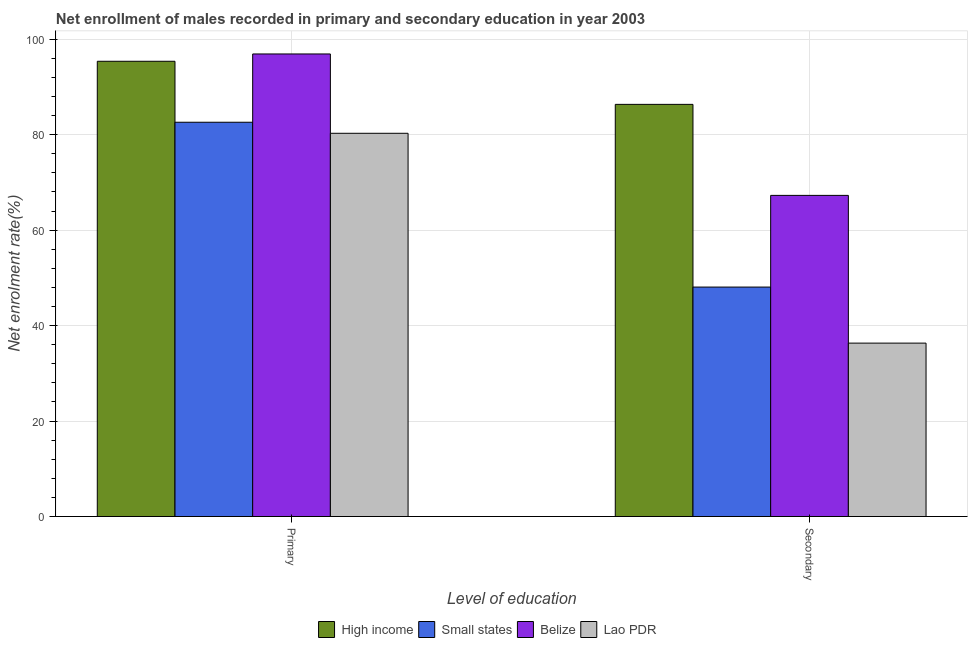How many different coloured bars are there?
Offer a very short reply. 4. How many groups of bars are there?
Provide a short and direct response. 2. Are the number of bars per tick equal to the number of legend labels?
Make the answer very short. Yes. Are the number of bars on each tick of the X-axis equal?
Keep it short and to the point. Yes. How many bars are there on the 1st tick from the left?
Offer a very short reply. 4. How many bars are there on the 1st tick from the right?
Your response must be concise. 4. What is the label of the 2nd group of bars from the left?
Offer a very short reply. Secondary. What is the enrollment rate in primary education in Lao PDR?
Keep it short and to the point. 80.28. Across all countries, what is the maximum enrollment rate in secondary education?
Give a very brief answer. 86.34. Across all countries, what is the minimum enrollment rate in primary education?
Give a very brief answer. 80.28. In which country was the enrollment rate in secondary education maximum?
Give a very brief answer. High income. In which country was the enrollment rate in primary education minimum?
Ensure brevity in your answer.  Lao PDR. What is the total enrollment rate in primary education in the graph?
Provide a succinct answer. 355.14. What is the difference between the enrollment rate in secondary education in Small states and that in Belize?
Offer a very short reply. -19.21. What is the difference between the enrollment rate in primary education in Belize and the enrollment rate in secondary education in High income?
Give a very brief answer. 10.56. What is the average enrollment rate in secondary education per country?
Offer a terse response. 59.5. What is the difference between the enrollment rate in secondary education and enrollment rate in primary education in High income?
Provide a short and direct response. -9.03. What is the ratio of the enrollment rate in primary education in Small states to that in Belize?
Your response must be concise. 0.85. Is the enrollment rate in primary education in Lao PDR less than that in Belize?
Keep it short and to the point. Yes. In how many countries, is the enrollment rate in primary education greater than the average enrollment rate in primary education taken over all countries?
Give a very brief answer. 2. What does the 1st bar from the left in Primary represents?
Your answer should be compact. High income. What does the 2nd bar from the right in Secondary represents?
Make the answer very short. Belize. How many countries are there in the graph?
Offer a very short reply. 4. Are the values on the major ticks of Y-axis written in scientific E-notation?
Keep it short and to the point. No. Does the graph contain grids?
Offer a very short reply. Yes. How many legend labels are there?
Keep it short and to the point. 4. What is the title of the graph?
Offer a terse response. Net enrollment of males recorded in primary and secondary education in year 2003. What is the label or title of the X-axis?
Your response must be concise. Level of education. What is the label or title of the Y-axis?
Your answer should be very brief. Net enrolment rate(%). What is the Net enrolment rate(%) of High income in Primary?
Ensure brevity in your answer.  95.36. What is the Net enrolment rate(%) in Small states in Primary?
Offer a terse response. 82.59. What is the Net enrolment rate(%) of Belize in Primary?
Your response must be concise. 96.9. What is the Net enrolment rate(%) of Lao PDR in Primary?
Your answer should be very brief. 80.28. What is the Net enrolment rate(%) in High income in Secondary?
Offer a terse response. 86.34. What is the Net enrolment rate(%) of Small states in Secondary?
Offer a terse response. 48.07. What is the Net enrolment rate(%) in Belize in Secondary?
Make the answer very short. 67.27. What is the Net enrolment rate(%) of Lao PDR in Secondary?
Keep it short and to the point. 36.32. Across all Level of education, what is the maximum Net enrolment rate(%) in High income?
Offer a terse response. 95.36. Across all Level of education, what is the maximum Net enrolment rate(%) in Small states?
Give a very brief answer. 82.59. Across all Level of education, what is the maximum Net enrolment rate(%) in Belize?
Your answer should be very brief. 96.9. Across all Level of education, what is the maximum Net enrolment rate(%) of Lao PDR?
Provide a succinct answer. 80.28. Across all Level of education, what is the minimum Net enrolment rate(%) in High income?
Provide a succinct answer. 86.34. Across all Level of education, what is the minimum Net enrolment rate(%) of Small states?
Provide a succinct answer. 48.07. Across all Level of education, what is the minimum Net enrolment rate(%) of Belize?
Your answer should be compact. 67.27. Across all Level of education, what is the minimum Net enrolment rate(%) of Lao PDR?
Your response must be concise. 36.32. What is the total Net enrolment rate(%) in High income in the graph?
Provide a succinct answer. 181.7. What is the total Net enrolment rate(%) of Small states in the graph?
Keep it short and to the point. 130.66. What is the total Net enrolment rate(%) of Belize in the graph?
Provide a succinct answer. 164.17. What is the total Net enrolment rate(%) of Lao PDR in the graph?
Give a very brief answer. 116.6. What is the difference between the Net enrolment rate(%) of High income in Primary and that in Secondary?
Your answer should be very brief. 9.03. What is the difference between the Net enrolment rate(%) of Small states in Primary and that in Secondary?
Make the answer very short. 34.53. What is the difference between the Net enrolment rate(%) in Belize in Primary and that in Secondary?
Keep it short and to the point. 29.63. What is the difference between the Net enrolment rate(%) in Lao PDR in Primary and that in Secondary?
Your response must be concise. 43.95. What is the difference between the Net enrolment rate(%) of High income in Primary and the Net enrolment rate(%) of Small states in Secondary?
Your response must be concise. 47.3. What is the difference between the Net enrolment rate(%) of High income in Primary and the Net enrolment rate(%) of Belize in Secondary?
Keep it short and to the point. 28.09. What is the difference between the Net enrolment rate(%) in High income in Primary and the Net enrolment rate(%) in Lao PDR in Secondary?
Give a very brief answer. 59.04. What is the difference between the Net enrolment rate(%) in Small states in Primary and the Net enrolment rate(%) in Belize in Secondary?
Offer a terse response. 15.32. What is the difference between the Net enrolment rate(%) of Small states in Primary and the Net enrolment rate(%) of Lao PDR in Secondary?
Make the answer very short. 46.27. What is the difference between the Net enrolment rate(%) of Belize in Primary and the Net enrolment rate(%) of Lao PDR in Secondary?
Give a very brief answer. 60.57. What is the average Net enrolment rate(%) in High income per Level of education?
Your answer should be very brief. 90.85. What is the average Net enrolment rate(%) in Small states per Level of education?
Provide a succinct answer. 65.33. What is the average Net enrolment rate(%) of Belize per Level of education?
Offer a very short reply. 82.08. What is the average Net enrolment rate(%) of Lao PDR per Level of education?
Keep it short and to the point. 58.3. What is the difference between the Net enrolment rate(%) in High income and Net enrolment rate(%) in Small states in Primary?
Offer a very short reply. 12.77. What is the difference between the Net enrolment rate(%) of High income and Net enrolment rate(%) of Belize in Primary?
Give a very brief answer. -1.53. What is the difference between the Net enrolment rate(%) in High income and Net enrolment rate(%) in Lao PDR in Primary?
Your answer should be very brief. 15.09. What is the difference between the Net enrolment rate(%) of Small states and Net enrolment rate(%) of Belize in Primary?
Provide a succinct answer. -14.31. What is the difference between the Net enrolment rate(%) of Small states and Net enrolment rate(%) of Lao PDR in Primary?
Provide a succinct answer. 2.31. What is the difference between the Net enrolment rate(%) of Belize and Net enrolment rate(%) of Lao PDR in Primary?
Your response must be concise. 16.62. What is the difference between the Net enrolment rate(%) in High income and Net enrolment rate(%) in Small states in Secondary?
Your answer should be compact. 38.27. What is the difference between the Net enrolment rate(%) of High income and Net enrolment rate(%) of Belize in Secondary?
Offer a terse response. 19.07. What is the difference between the Net enrolment rate(%) of High income and Net enrolment rate(%) of Lao PDR in Secondary?
Your answer should be compact. 50.01. What is the difference between the Net enrolment rate(%) in Small states and Net enrolment rate(%) in Belize in Secondary?
Provide a short and direct response. -19.21. What is the difference between the Net enrolment rate(%) of Small states and Net enrolment rate(%) of Lao PDR in Secondary?
Give a very brief answer. 11.74. What is the difference between the Net enrolment rate(%) of Belize and Net enrolment rate(%) of Lao PDR in Secondary?
Provide a succinct answer. 30.95. What is the ratio of the Net enrolment rate(%) of High income in Primary to that in Secondary?
Offer a terse response. 1.1. What is the ratio of the Net enrolment rate(%) in Small states in Primary to that in Secondary?
Your answer should be compact. 1.72. What is the ratio of the Net enrolment rate(%) in Belize in Primary to that in Secondary?
Offer a very short reply. 1.44. What is the ratio of the Net enrolment rate(%) of Lao PDR in Primary to that in Secondary?
Ensure brevity in your answer.  2.21. What is the difference between the highest and the second highest Net enrolment rate(%) in High income?
Provide a short and direct response. 9.03. What is the difference between the highest and the second highest Net enrolment rate(%) in Small states?
Your answer should be very brief. 34.53. What is the difference between the highest and the second highest Net enrolment rate(%) in Belize?
Your response must be concise. 29.63. What is the difference between the highest and the second highest Net enrolment rate(%) of Lao PDR?
Offer a very short reply. 43.95. What is the difference between the highest and the lowest Net enrolment rate(%) of High income?
Keep it short and to the point. 9.03. What is the difference between the highest and the lowest Net enrolment rate(%) in Small states?
Your answer should be compact. 34.53. What is the difference between the highest and the lowest Net enrolment rate(%) in Belize?
Give a very brief answer. 29.63. What is the difference between the highest and the lowest Net enrolment rate(%) of Lao PDR?
Your answer should be compact. 43.95. 